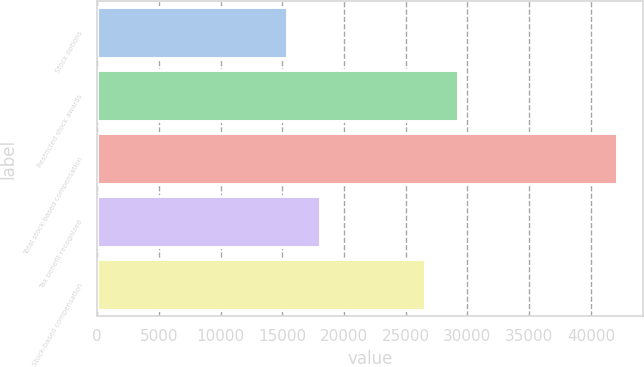Convert chart to OTSL. <chart><loc_0><loc_0><loc_500><loc_500><bar_chart><fcel>Stock options<fcel>Restricted stock awards<fcel>Total stock-based compensation<fcel>Tax benefit recognized<fcel>Stock-based compensation<nl><fcel>15408<fcel>29236.4<fcel>42132<fcel>18080.4<fcel>26564<nl></chart> 